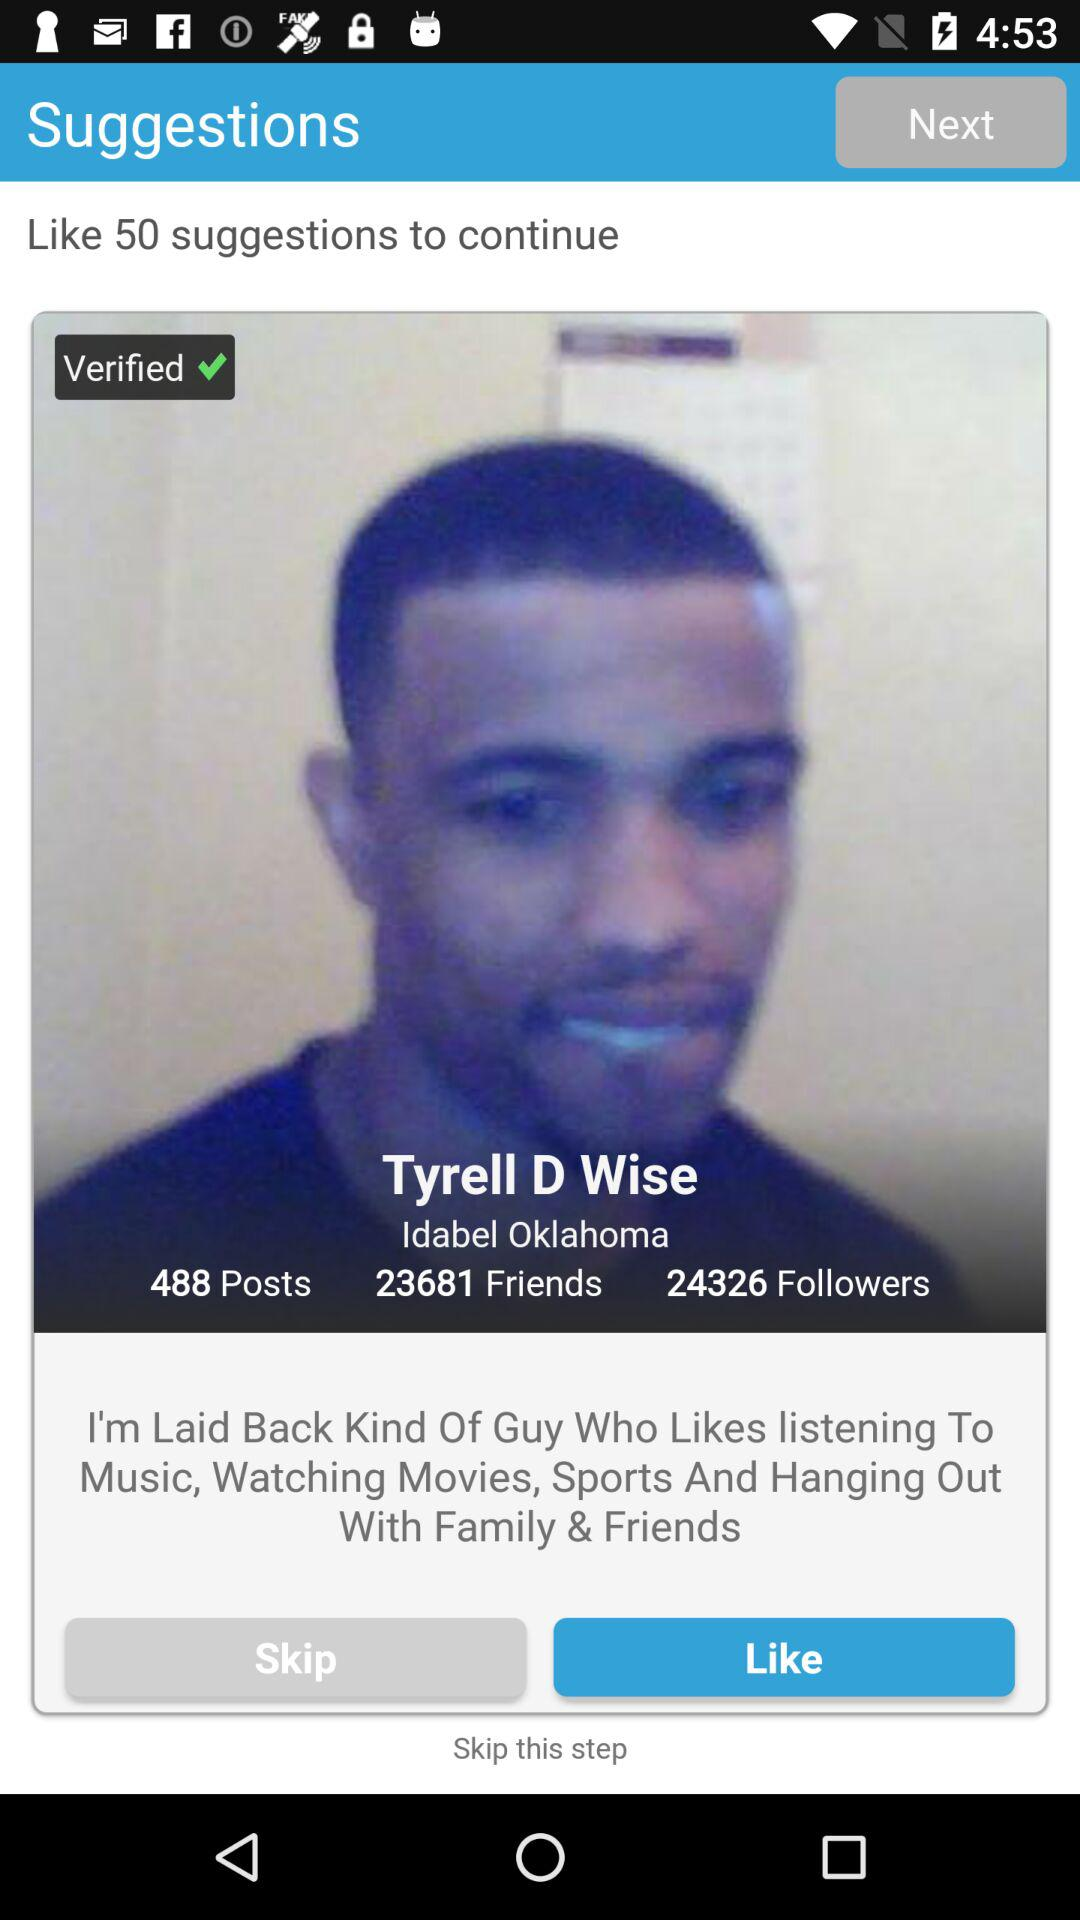How many suggestions do I have to like to continue? You have to like 50 suggestions to continue. 